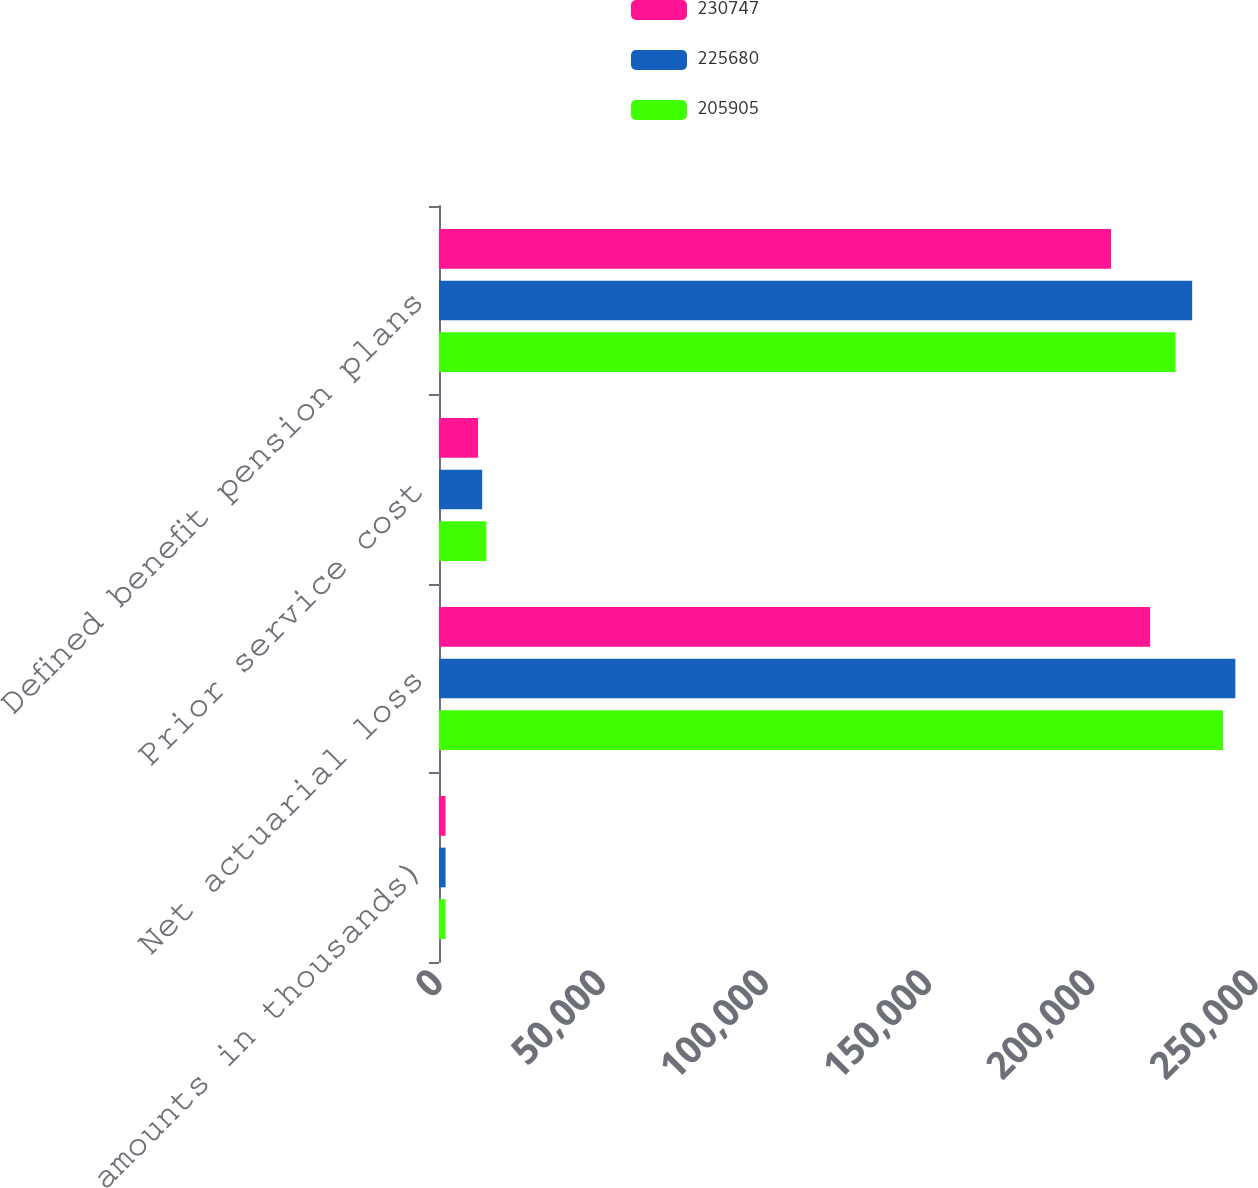Convert chart. <chart><loc_0><loc_0><loc_500><loc_500><stacked_bar_chart><ecel><fcel>(dollar amounts in thousands)<fcel>Net actuarial loss<fcel>Prior service cost<fcel>Defined benefit pension plans<nl><fcel>230747<fcel>2016<fcel>217863<fcel>11958<fcel>205905<nl><fcel>225680<fcel>2015<fcel>243984<fcel>13237<fcel>230747<nl><fcel>205905<fcel>2014<fcel>240197<fcel>14517<fcel>225680<nl></chart> 